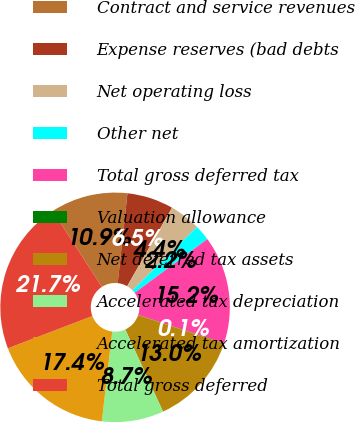Convert chart. <chart><loc_0><loc_0><loc_500><loc_500><pie_chart><fcel>Contract and service revenues<fcel>Expense reserves (bad debts<fcel>Net operating loss<fcel>Other net<fcel>Total gross deferred tax<fcel>Valuation allowance<fcel>Net deferred tax assets<fcel>Accelerated tax depreciation<fcel>Accelerated tax amortization<fcel>Total gross deferred<nl><fcel>10.86%<fcel>6.54%<fcel>4.38%<fcel>2.22%<fcel>15.19%<fcel>0.06%<fcel>13.03%<fcel>8.7%<fcel>17.35%<fcel>21.67%<nl></chart> 